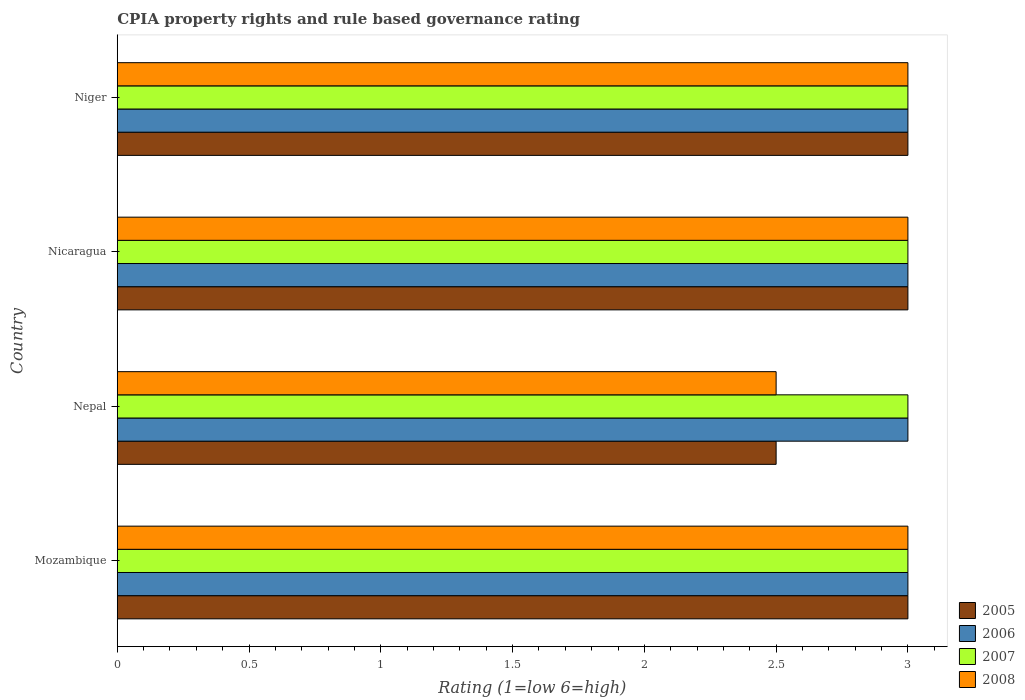How many groups of bars are there?
Your answer should be compact. 4. How many bars are there on the 4th tick from the bottom?
Provide a succinct answer. 4. What is the label of the 2nd group of bars from the top?
Give a very brief answer. Nicaragua. In how many cases, is the number of bars for a given country not equal to the number of legend labels?
Offer a terse response. 0. Across all countries, what is the maximum CPIA rating in 2005?
Offer a very short reply. 3. In which country was the CPIA rating in 2007 maximum?
Ensure brevity in your answer.  Mozambique. In which country was the CPIA rating in 2008 minimum?
Your response must be concise. Nepal. What is the average CPIA rating in 2005 per country?
Your response must be concise. 2.88. What is the ratio of the CPIA rating in 2005 in Nepal to that in Nicaragua?
Provide a succinct answer. 0.83. Is the CPIA rating in 2007 in Nepal less than that in Niger?
Ensure brevity in your answer.  No. What is the difference between the highest and the lowest CPIA rating in 2006?
Your answer should be compact. 0. In how many countries, is the CPIA rating in 2008 greater than the average CPIA rating in 2008 taken over all countries?
Make the answer very short. 3. Is the sum of the CPIA rating in 2005 in Mozambique and Nepal greater than the maximum CPIA rating in 2007 across all countries?
Keep it short and to the point. Yes. Is it the case that in every country, the sum of the CPIA rating in 2007 and CPIA rating in 2005 is greater than the CPIA rating in 2008?
Make the answer very short. Yes. How many bars are there?
Give a very brief answer. 16. What is the difference between two consecutive major ticks on the X-axis?
Your answer should be compact. 0.5. How many legend labels are there?
Your answer should be very brief. 4. What is the title of the graph?
Your response must be concise. CPIA property rights and rule based governance rating. Does "1997" appear as one of the legend labels in the graph?
Ensure brevity in your answer.  No. What is the label or title of the X-axis?
Give a very brief answer. Rating (1=low 6=high). What is the Rating (1=low 6=high) of 2006 in Mozambique?
Keep it short and to the point. 3. What is the Rating (1=low 6=high) of 2008 in Mozambique?
Give a very brief answer. 3. What is the Rating (1=low 6=high) of 2006 in Nepal?
Make the answer very short. 3. What is the Rating (1=low 6=high) of 2007 in Nepal?
Your response must be concise. 3. What is the Rating (1=low 6=high) of 2008 in Nepal?
Ensure brevity in your answer.  2.5. What is the Rating (1=low 6=high) of 2005 in Nicaragua?
Offer a very short reply. 3. What is the Rating (1=low 6=high) in 2008 in Nicaragua?
Your response must be concise. 3. What is the Rating (1=low 6=high) of 2005 in Niger?
Give a very brief answer. 3. What is the Rating (1=low 6=high) of 2006 in Niger?
Provide a succinct answer. 3. What is the Rating (1=low 6=high) of 2007 in Niger?
Your answer should be compact. 3. What is the Rating (1=low 6=high) of 2008 in Niger?
Provide a short and direct response. 3. Across all countries, what is the maximum Rating (1=low 6=high) of 2007?
Ensure brevity in your answer.  3. Across all countries, what is the maximum Rating (1=low 6=high) of 2008?
Make the answer very short. 3. Across all countries, what is the minimum Rating (1=low 6=high) of 2006?
Offer a very short reply. 3. What is the total Rating (1=low 6=high) in 2005 in the graph?
Keep it short and to the point. 11.5. What is the total Rating (1=low 6=high) in 2008 in the graph?
Offer a very short reply. 11.5. What is the difference between the Rating (1=low 6=high) of 2006 in Mozambique and that in Nepal?
Make the answer very short. 0. What is the difference between the Rating (1=low 6=high) in 2007 in Mozambique and that in Nicaragua?
Your answer should be compact. 0. What is the difference between the Rating (1=low 6=high) in 2007 in Mozambique and that in Niger?
Your answer should be very brief. 0. What is the difference between the Rating (1=low 6=high) of 2008 in Mozambique and that in Niger?
Your answer should be compact. 0. What is the difference between the Rating (1=low 6=high) of 2005 in Nepal and that in Nicaragua?
Provide a short and direct response. -0.5. What is the difference between the Rating (1=low 6=high) of 2006 in Nepal and that in Nicaragua?
Your answer should be compact. 0. What is the difference between the Rating (1=low 6=high) of 2007 in Nepal and that in Nicaragua?
Provide a short and direct response. 0. What is the difference between the Rating (1=low 6=high) in 2008 in Nepal and that in Nicaragua?
Provide a short and direct response. -0.5. What is the difference between the Rating (1=low 6=high) in 2005 in Nepal and that in Niger?
Give a very brief answer. -0.5. What is the difference between the Rating (1=low 6=high) of 2006 in Nepal and that in Niger?
Offer a very short reply. 0. What is the difference between the Rating (1=low 6=high) of 2008 in Nepal and that in Niger?
Your response must be concise. -0.5. What is the difference between the Rating (1=low 6=high) in 2006 in Nicaragua and that in Niger?
Give a very brief answer. 0. What is the difference between the Rating (1=low 6=high) of 2008 in Nicaragua and that in Niger?
Make the answer very short. 0. What is the difference between the Rating (1=low 6=high) of 2005 in Mozambique and the Rating (1=low 6=high) of 2007 in Nepal?
Provide a short and direct response. 0. What is the difference between the Rating (1=low 6=high) of 2005 in Mozambique and the Rating (1=low 6=high) of 2008 in Nepal?
Your answer should be compact. 0.5. What is the difference between the Rating (1=low 6=high) of 2006 in Mozambique and the Rating (1=low 6=high) of 2007 in Nepal?
Your answer should be compact. 0. What is the difference between the Rating (1=low 6=high) of 2005 in Mozambique and the Rating (1=low 6=high) of 2006 in Nicaragua?
Ensure brevity in your answer.  0. What is the difference between the Rating (1=low 6=high) of 2006 in Mozambique and the Rating (1=low 6=high) of 2007 in Nicaragua?
Ensure brevity in your answer.  0. What is the difference between the Rating (1=low 6=high) in 2006 in Mozambique and the Rating (1=low 6=high) in 2008 in Nicaragua?
Offer a very short reply. 0. What is the difference between the Rating (1=low 6=high) in 2005 in Mozambique and the Rating (1=low 6=high) in 2007 in Niger?
Provide a short and direct response. 0. What is the difference between the Rating (1=low 6=high) of 2005 in Mozambique and the Rating (1=low 6=high) of 2008 in Niger?
Your answer should be compact. 0. What is the difference between the Rating (1=low 6=high) of 2006 in Mozambique and the Rating (1=low 6=high) of 2008 in Niger?
Offer a terse response. 0. What is the difference between the Rating (1=low 6=high) of 2007 in Mozambique and the Rating (1=low 6=high) of 2008 in Niger?
Provide a short and direct response. 0. What is the difference between the Rating (1=low 6=high) in 2005 in Nepal and the Rating (1=low 6=high) in 2008 in Nicaragua?
Your answer should be very brief. -0.5. What is the difference between the Rating (1=low 6=high) of 2006 in Nepal and the Rating (1=low 6=high) of 2008 in Nicaragua?
Offer a terse response. 0. What is the difference between the Rating (1=low 6=high) in 2007 in Nepal and the Rating (1=low 6=high) in 2008 in Nicaragua?
Make the answer very short. 0. What is the difference between the Rating (1=low 6=high) in 2007 in Nepal and the Rating (1=low 6=high) in 2008 in Niger?
Give a very brief answer. 0. What is the difference between the Rating (1=low 6=high) of 2005 in Nicaragua and the Rating (1=low 6=high) of 2007 in Niger?
Your response must be concise. 0. What is the difference between the Rating (1=low 6=high) in 2005 in Nicaragua and the Rating (1=low 6=high) in 2008 in Niger?
Provide a succinct answer. 0. What is the difference between the Rating (1=low 6=high) of 2006 in Nicaragua and the Rating (1=low 6=high) of 2007 in Niger?
Your response must be concise. 0. What is the difference between the Rating (1=low 6=high) in 2007 in Nicaragua and the Rating (1=low 6=high) in 2008 in Niger?
Give a very brief answer. 0. What is the average Rating (1=low 6=high) of 2005 per country?
Offer a very short reply. 2.88. What is the average Rating (1=low 6=high) in 2006 per country?
Make the answer very short. 3. What is the average Rating (1=low 6=high) in 2008 per country?
Offer a very short reply. 2.88. What is the difference between the Rating (1=low 6=high) in 2005 and Rating (1=low 6=high) in 2006 in Mozambique?
Keep it short and to the point. 0. What is the difference between the Rating (1=low 6=high) of 2006 and Rating (1=low 6=high) of 2007 in Mozambique?
Offer a terse response. 0. What is the difference between the Rating (1=low 6=high) of 2007 and Rating (1=low 6=high) of 2008 in Mozambique?
Provide a short and direct response. 0. What is the difference between the Rating (1=low 6=high) in 2005 and Rating (1=low 6=high) in 2006 in Nepal?
Ensure brevity in your answer.  -0.5. What is the difference between the Rating (1=low 6=high) in 2005 and Rating (1=low 6=high) in 2008 in Nepal?
Your answer should be very brief. 0. What is the difference between the Rating (1=low 6=high) of 2005 and Rating (1=low 6=high) of 2006 in Nicaragua?
Give a very brief answer. 0. What is the difference between the Rating (1=low 6=high) of 2005 and Rating (1=low 6=high) of 2008 in Nicaragua?
Provide a succinct answer. 0. What is the difference between the Rating (1=low 6=high) of 2006 and Rating (1=low 6=high) of 2007 in Nicaragua?
Offer a terse response. 0. What is the difference between the Rating (1=low 6=high) of 2005 and Rating (1=low 6=high) of 2006 in Niger?
Give a very brief answer. 0. What is the difference between the Rating (1=low 6=high) in 2005 and Rating (1=low 6=high) in 2008 in Niger?
Give a very brief answer. 0. What is the difference between the Rating (1=low 6=high) of 2006 and Rating (1=low 6=high) of 2007 in Niger?
Offer a very short reply. 0. What is the ratio of the Rating (1=low 6=high) in 2005 in Mozambique to that in Nepal?
Provide a short and direct response. 1.2. What is the ratio of the Rating (1=low 6=high) in 2008 in Mozambique to that in Nepal?
Provide a succinct answer. 1.2. What is the ratio of the Rating (1=low 6=high) in 2006 in Mozambique to that in Nicaragua?
Offer a terse response. 1. What is the ratio of the Rating (1=low 6=high) of 2007 in Mozambique to that in Nicaragua?
Provide a succinct answer. 1. What is the ratio of the Rating (1=low 6=high) of 2005 in Mozambique to that in Niger?
Your answer should be very brief. 1. What is the ratio of the Rating (1=low 6=high) of 2006 in Mozambique to that in Niger?
Your response must be concise. 1. What is the ratio of the Rating (1=low 6=high) in 2008 in Mozambique to that in Niger?
Provide a succinct answer. 1. What is the ratio of the Rating (1=low 6=high) of 2005 in Nepal to that in Nicaragua?
Your answer should be compact. 0.83. What is the ratio of the Rating (1=low 6=high) in 2006 in Nepal to that in Nicaragua?
Ensure brevity in your answer.  1. What is the ratio of the Rating (1=low 6=high) of 2005 in Nepal to that in Niger?
Your answer should be very brief. 0.83. What is the ratio of the Rating (1=low 6=high) of 2006 in Nepal to that in Niger?
Offer a terse response. 1. What is the ratio of the Rating (1=low 6=high) of 2008 in Nepal to that in Niger?
Give a very brief answer. 0.83. What is the ratio of the Rating (1=low 6=high) in 2005 in Nicaragua to that in Niger?
Provide a short and direct response. 1. What is the ratio of the Rating (1=low 6=high) in 2006 in Nicaragua to that in Niger?
Offer a very short reply. 1. What is the ratio of the Rating (1=low 6=high) in 2007 in Nicaragua to that in Niger?
Your answer should be very brief. 1. What is the difference between the highest and the second highest Rating (1=low 6=high) in 2007?
Your answer should be compact. 0. What is the difference between the highest and the lowest Rating (1=low 6=high) in 2005?
Provide a succinct answer. 0.5. What is the difference between the highest and the lowest Rating (1=low 6=high) in 2006?
Your answer should be very brief. 0. What is the difference between the highest and the lowest Rating (1=low 6=high) in 2007?
Your response must be concise. 0. What is the difference between the highest and the lowest Rating (1=low 6=high) in 2008?
Ensure brevity in your answer.  0.5. 